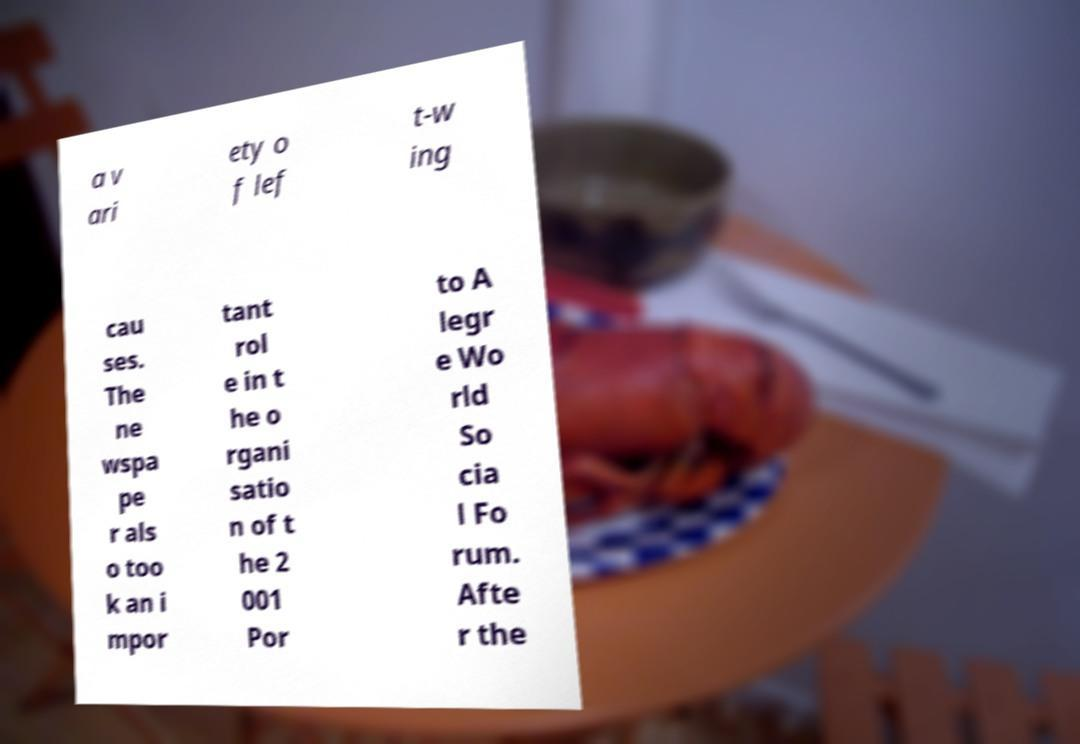Please identify and transcribe the text found in this image. a v ari ety o f lef t-w ing cau ses. The ne wspa pe r als o too k an i mpor tant rol e in t he o rgani satio n of t he 2 001 Por to A legr e Wo rld So cia l Fo rum. Afte r the 